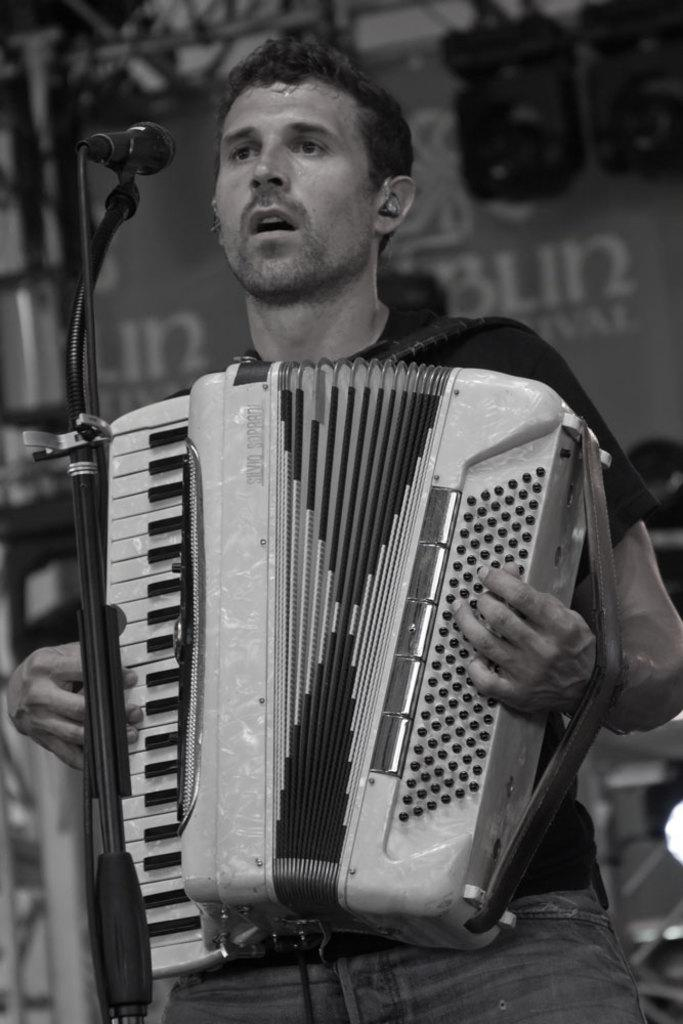What is the person in the image doing? The person is standing in front of a mic and playing a musical instrument. What can be seen in the background of the image? There is a banner in the background. What is the color scheme of the image? The image is black and white. What type of plate is being used to play the musical instrument in the image? There is no plate present in the image, and the person is playing a musical instrument, not a plate. Can you see any chains attached to the person in the image? There are no chains visible in the image. 